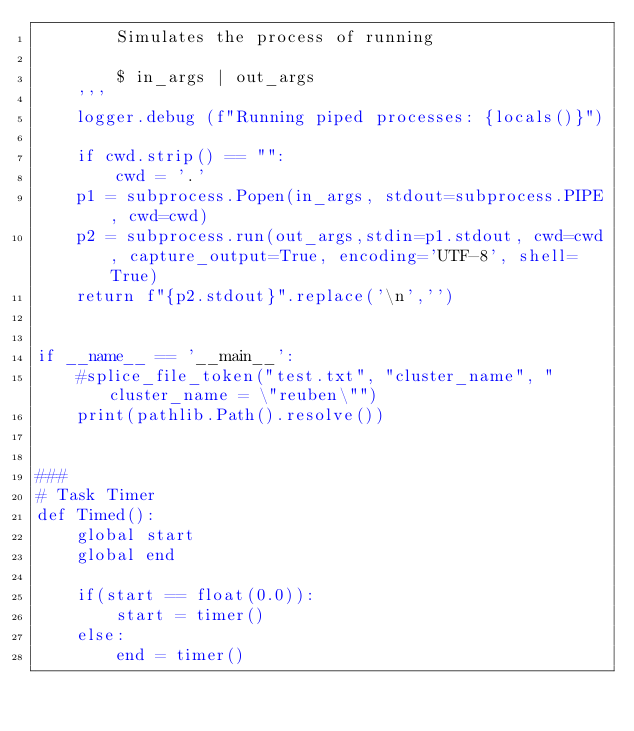Convert code to text. <code><loc_0><loc_0><loc_500><loc_500><_Python_>        Simulates the process of running

        $ in_args | out_args
    '''
    logger.debug (f"Running piped processes: {locals()}")

    if cwd.strip() == "":
        cwd = '.'
    p1 = subprocess.Popen(in_args, stdout=subprocess.PIPE, cwd=cwd)
    p2 = subprocess.run(out_args,stdin=p1.stdout, cwd=cwd, capture_output=True, encoding='UTF-8', shell=True)
    return f"{p2.stdout}".replace('\n','')


if __name__ == '__main__':
    #splice_file_token("test.txt", "cluster_name", "cluster_name = \"reuben\"")
    print(pathlib.Path().resolve())


###
# Task Timer
def Timed():
    global start
    global end

    if(start == float(0.0)):
        start = timer()
    else:
        end = timer()</code> 